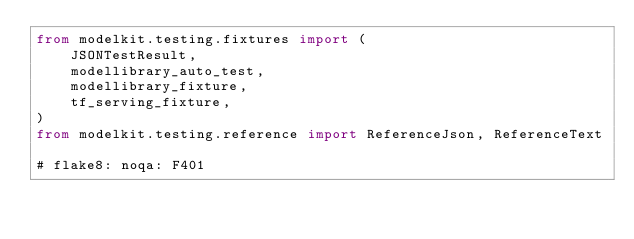<code> <loc_0><loc_0><loc_500><loc_500><_Python_>from modelkit.testing.fixtures import (
    JSONTestResult,
    modellibrary_auto_test,
    modellibrary_fixture,
    tf_serving_fixture,
)
from modelkit.testing.reference import ReferenceJson, ReferenceText

# flake8: noqa: F401
</code> 